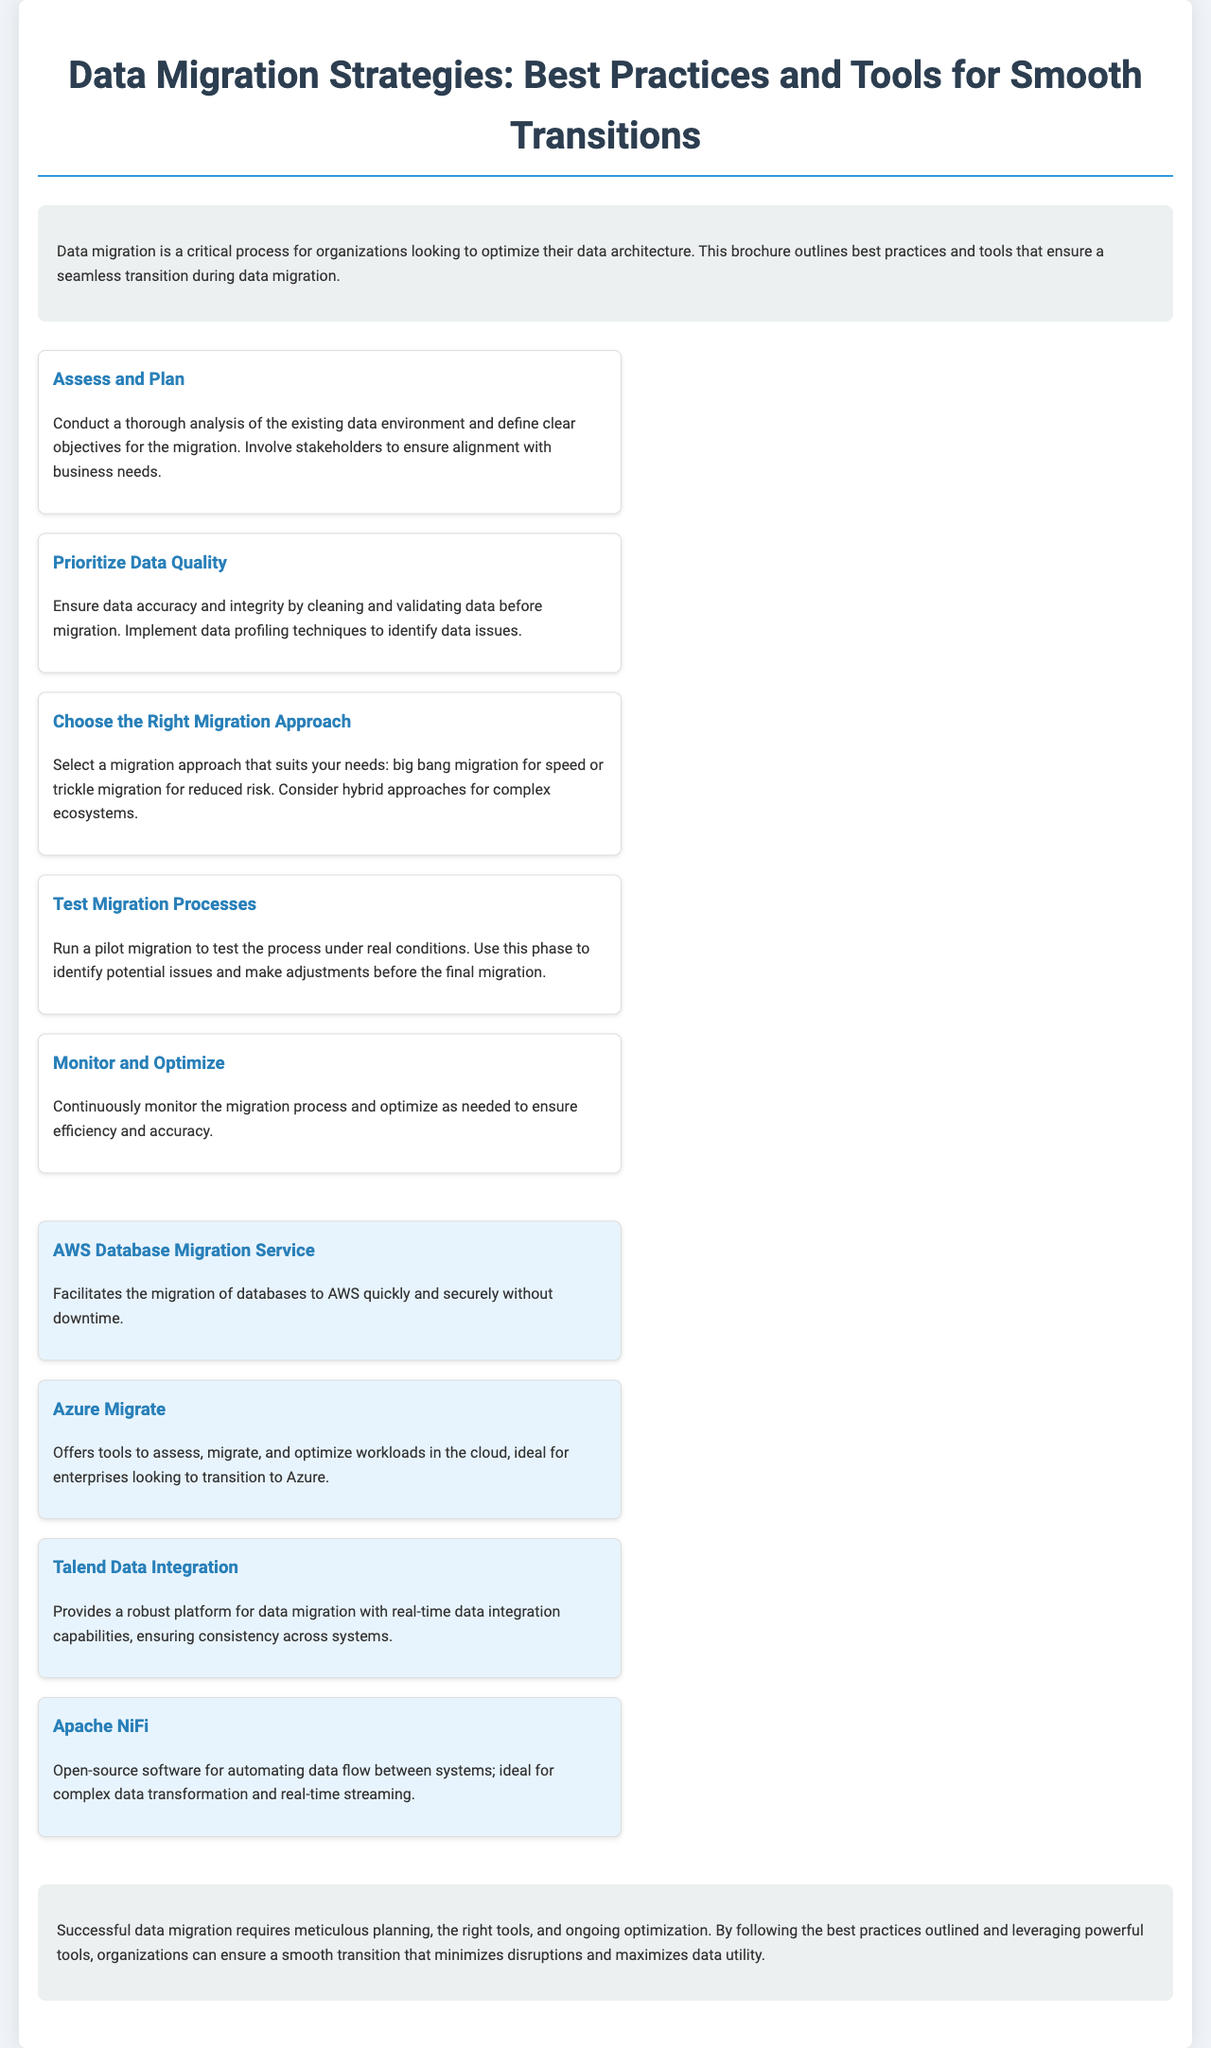What is the title of the brochure? The title is the main heading of the document that indicates the topic it covers.
Answer: Data Migration Strategies: Best Practices and Tools for Smooth Transitions How many best practices are listed? The document outlines specific best practices for data migration, typically numbered in the body.
Answer: Five What is the first step in the best practices? The first best practice is detailed as the initial recommendation for organizations during data migration.
Answer: Assess and Plan What tool is mentioned for migrating databases to AWS? This tool is specifically mentioned in the document as aiding the transition for AWS customers.
Answer: AWS Database Migration Service What type of migration does the document suggest for reduced risk? The document highlights different types of migration approaches suitable for various situations.
Answer: Trickle migration Which tool is described as open-source for automating data flow? This tool is specifically identified in the document for its capabilities in handling data transfer processes.
Answer: Apache NiFi What is emphasized as essential for ensuring accuracy in data migration? This concept is reiterated throughout the best practices section as necessary for success.
Answer: Data quality What is the concluding message about successful data migration? The conclusion sums up the key points regarding the overarching theme of the document.
Answer: Meticulous planning 